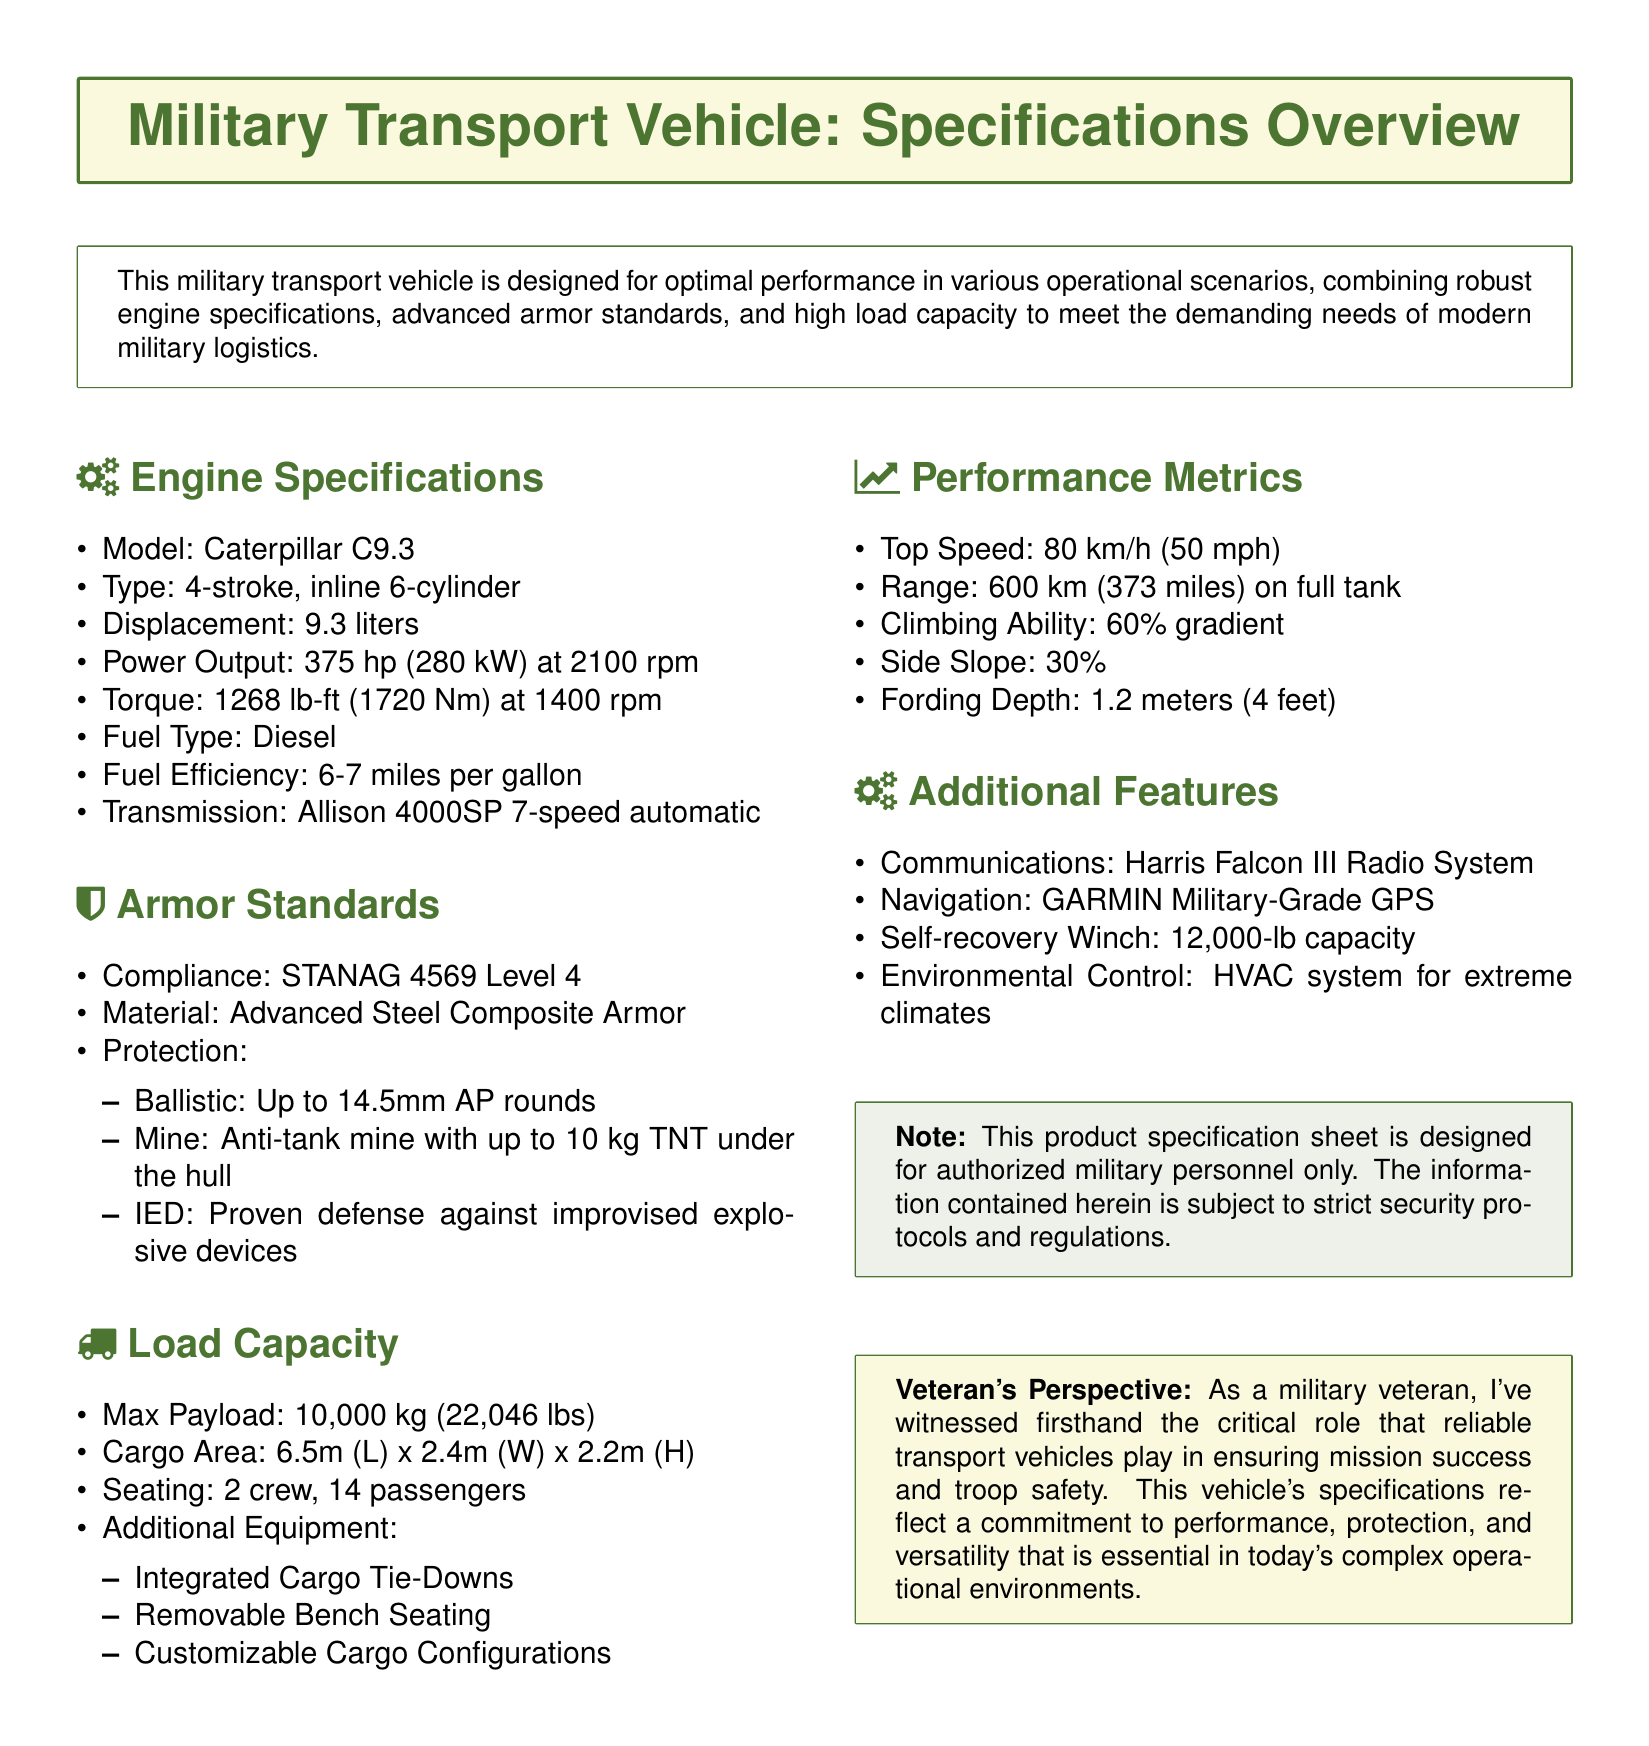What is the engine model? The document specifies the engine model as "Caterpillar C9.3."
Answer: Caterpillar C9.3 What is the power output of the engine? According to the document, the power output is "375 hp (280 kW) at 2100 rpm."
Answer: 375 hp (280 kW) What is the level of armor compliance? The document states the armor compliance is "STANAG 4569 Level 4."
Answer: STANAG 4569 Level 4 What type of armor material is used? The specification mentions that the armor material is "Advanced Steel Composite Armor."
Answer: Advanced Steel Composite Armor What is the maximum payload capacity? The document indicates the maximum payload capacity as "10,000 kg (22,046 lbs)."
Answer: 10,000 kg (22,046 lbs) What is the fuel efficiency range? The fuel efficiency is provided as "6-7 miles per gallon."
Answer: 6-7 miles per gallon What is the top speed of the vehicle? The document specifies the top speed as "80 km/h (50 mph)."
Answer: 80 km/h (50 mph) What feature aids in cargo configuration? The document lists "Customizable Cargo Configurations" as an additional feature for cargo.
Answer: Customizable Cargo Configurations How many passengers can the vehicle accommodate? The seating specifications state that the vehicle can hold "14 passengers."
Answer: 14 passengers 